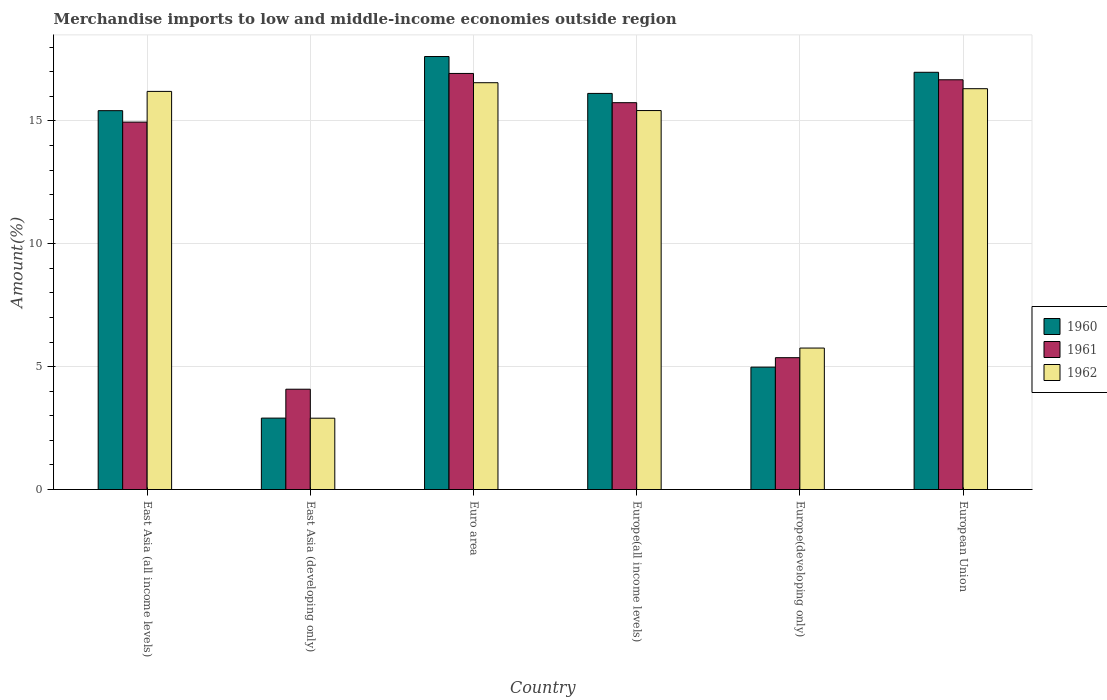How many groups of bars are there?
Your answer should be compact. 6. Are the number of bars per tick equal to the number of legend labels?
Offer a very short reply. Yes. How many bars are there on the 4th tick from the right?
Keep it short and to the point. 3. What is the label of the 4th group of bars from the left?
Provide a short and direct response. Europe(all income levels). In how many cases, is the number of bars for a given country not equal to the number of legend labels?
Keep it short and to the point. 0. What is the percentage of amount earned from merchandise imports in 1961 in Euro area?
Make the answer very short. 16.93. Across all countries, what is the maximum percentage of amount earned from merchandise imports in 1960?
Ensure brevity in your answer.  17.62. Across all countries, what is the minimum percentage of amount earned from merchandise imports in 1960?
Give a very brief answer. 2.91. In which country was the percentage of amount earned from merchandise imports in 1961 minimum?
Provide a short and direct response. East Asia (developing only). What is the total percentage of amount earned from merchandise imports in 1960 in the graph?
Your response must be concise. 74.01. What is the difference between the percentage of amount earned from merchandise imports in 1962 in East Asia (all income levels) and that in East Asia (developing only)?
Make the answer very short. 13.3. What is the difference between the percentage of amount earned from merchandise imports in 1961 in Euro area and the percentage of amount earned from merchandise imports in 1960 in Europe(all income levels)?
Ensure brevity in your answer.  0.81. What is the average percentage of amount earned from merchandise imports in 1961 per country?
Give a very brief answer. 12.29. What is the difference between the percentage of amount earned from merchandise imports of/in 1962 and percentage of amount earned from merchandise imports of/in 1960 in Euro area?
Provide a short and direct response. -1.07. In how many countries, is the percentage of amount earned from merchandise imports in 1962 greater than 10 %?
Provide a succinct answer. 4. What is the ratio of the percentage of amount earned from merchandise imports in 1960 in Europe(all income levels) to that in European Union?
Your answer should be very brief. 0.95. Is the percentage of amount earned from merchandise imports in 1961 in East Asia (developing only) less than that in European Union?
Keep it short and to the point. Yes. Is the difference between the percentage of amount earned from merchandise imports in 1962 in Euro area and Europe(all income levels) greater than the difference between the percentage of amount earned from merchandise imports in 1960 in Euro area and Europe(all income levels)?
Your answer should be compact. No. What is the difference between the highest and the second highest percentage of amount earned from merchandise imports in 1962?
Provide a succinct answer. 0.24. What is the difference between the highest and the lowest percentage of amount earned from merchandise imports in 1962?
Give a very brief answer. 13.65. Is the sum of the percentage of amount earned from merchandise imports in 1962 in East Asia (developing only) and European Union greater than the maximum percentage of amount earned from merchandise imports in 1960 across all countries?
Your answer should be very brief. Yes. What does the 2nd bar from the left in European Union represents?
Make the answer very short. 1961. Are all the bars in the graph horizontal?
Provide a succinct answer. No. How many countries are there in the graph?
Ensure brevity in your answer.  6. Are the values on the major ticks of Y-axis written in scientific E-notation?
Your answer should be compact. No. Does the graph contain any zero values?
Keep it short and to the point. No. How many legend labels are there?
Your answer should be very brief. 3. How are the legend labels stacked?
Make the answer very short. Vertical. What is the title of the graph?
Your response must be concise. Merchandise imports to low and middle-income economies outside region. What is the label or title of the Y-axis?
Your answer should be very brief. Amount(%). What is the Amount(%) of 1960 in East Asia (all income levels)?
Ensure brevity in your answer.  15.41. What is the Amount(%) of 1961 in East Asia (all income levels)?
Provide a short and direct response. 14.95. What is the Amount(%) in 1962 in East Asia (all income levels)?
Provide a succinct answer. 16.2. What is the Amount(%) of 1960 in East Asia (developing only)?
Ensure brevity in your answer.  2.91. What is the Amount(%) in 1961 in East Asia (developing only)?
Your response must be concise. 4.08. What is the Amount(%) of 1962 in East Asia (developing only)?
Provide a succinct answer. 2.9. What is the Amount(%) in 1960 in Euro area?
Provide a succinct answer. 17.62. What is the Amount(%) of 1961 in Euro area?
Your answer should be compact. 16.93. What is the Amount(%) in 1962 in Euro area?
Give a very brief answer. 16.55. What is the Amount(%) in 1960 in Europe(all income levels)?
Your response must be concise. 16.12. What is the Amount(%) of 1961 in Europe(all income levels)?
Provide a short and direct response. 15.74. What is the Amount(%) in 1962 in Europe(all income levels)?
Your response must be concise. 15.42. What is the Amount(%) of 1960 in Europe(developing only)?
Provide a succinct answer. 4.98. What is the Amount(%) of 1961 in Europe(developing only)?
Ensure brevity in your answer.  5.36. What is the Amount(%) in 1962 in Europe(developing only)?
Your response must be concise. 5.76. What is the Amount(%) of 1960 in European Union?
Your answer should be very brief. 16.98. What is the Amount(%) of 1961 in European Union?
Make the answer very short. 16.67. What is the Amount(%) of 1962 in European Union?
Provide a short and direct response. 16.31. Across all countries, what is the maximum Amount(%) of 1960?
Make the answer very short. 17.62. Across all countries, what is the maximum Amount(%) in 1961?
Make the answer very short. 16.93. Across all countries, what is the maximum Amount(%) of 1962?
Give a very brief answer. 16.55. Across all countries, what is the minimum Amount(%) of 1960?
Your response must be concise. 2.91. Across all countries, what is the minimum Amount(%) of 1961?
Your answer should be compact. 4.08. Across all countries, what is the minimum Amount(%) in 1962?
Your response must be concise. 2.9. What is the total Amount(%) in 1960 in the graph?
Your answer should be very brief. 74.01. What is the total Amount(%) of 1961 in the graph?
Offer a terse response. 73.73. What is the total Amount(%) of 1962 in the graph?
Provide a short and direct response. 73.14. What is the difference between the Amount(%) of 1960 in East Asia (all income levels) and that in East Asia (developing only)?
Give a very brief answer. 12.51. What is the difference between the Amount(%) of 1961 in East Asia (all income levels) and that in East Asia (developing only)?
Your answer should be very brief. 10.87. What is the difference between the Amount(%) in 1962 in East Asia (all income levels) and that in East Asia (developing only)?
Provide a succinct answer. 13.3. What is the difference between the Amount(%) in 1960 in East Asia (all income levels) and that in Euro area?
Ensure brevity in your answer.  -2.2. What is the difference between the Amount(%) in 1961 in East Asia (all income levels) and that in Euro area?
Provide a succinct answer. -1.98. What is the difference between the Amount(%) in 1962 in East Asia (all income levels) and that in Euro area?
Offer a very short reply. -0.35. What is the difference between the Amount(%) of 1960 in East Asia (all income levels) and that in Europe(all income levels)?
Provide a short and direct response. -0.7. What is the difference between the Amount(%) in 1961 in East Asia (all income levels) and that in Europe(all income levels)?
Your answer should be very brief. -0.79. What is the difference between the Amount(%) of 1962 in East Asia (all income levels) and that in Europe(all income levels)?
Your response must be concise. 0.78. What is the difference between the Amount(%) of 1960 in East Asia (all income levels) and that in Europe(developing only)?
Ensure brevity in your answer.  10.43. What is the difference between the Amount(%) of 1961 in East Asia (all income levels) and that in Europe(developing only)?
Your response must be concise. 9.58. What is the difference between the Amount(%) in 1962 in East Asia (all income levels) and that in Europe(developing only)?
Your response must be concise. 10.44. What is the difference between the Amount(%) of 1960 in East Asia (all income levels) and that in European Union?
Keep it short and to the point. -1.56. What is the difference between the Amount(%) in 1961 in East Asia (all income levels) and that in European Union?
Provide a succinct answer. -1.72. What is the difference between the Amount(%) of 1962 in East Asia (all income levels) and that in European Union?
Your answer should be very brief. -0.11. What is the difference between the Amount(%) of 1960 in East Asia (developing only) and that in Euro area?
Provide a succinct answer. -14.71. What is the difference between the Amount(%) in 1961 in East Asia (developing only) and that in Euro area?
Ensure brevity in your answer.  -12.85. What is the difference between the Amount(%) of 1962 in East Asia (developing only) and that in Euro area?
Provide a short and direct response. -13.65. What is the difference between the Amount(%) of 1960 in East Asia (developing only) and that in Europe(all income levels)?
Provide a succinct answer. -13.21. What is the difference between the Amount(%) of 1961 in East Asia (developing only) and that in Europe(all income levels)?
Make the answer very short. -11.66. What is the difference between the Amount(%) of 1962 in East Asia (developing only) and that in Europe(all income levels)?
Ensure brevity in your answer.  -12.52. What is the difference between the Amount(%) in 1960 in East Asia (developing only) and that in Europe(developing only)?
Provide a succinct answer. -2.07. What is the difference between the Amount(%) of 1961 in East Asia (developing only) and that in Europe(developing only)?
Ensure brevity in your answer.  -1.28. What is the difference between the Amount(%) in 1962 in East Asia (developing only) and that in Europe(developing only)?
Provide a short and direct response. -2.85. What is the difference between the Amount(%) of 1960 in East Asia (developing only) and that in European Union?
Make the answer very short. -14.07. What is the difference between the Amount(%) in 1961 in East Asia (developing only) and that in European Union?
Provide a succinct answer. -12.59. What is the difference between the Amount(%) in 1962 in East Asia (developing only) and that in European Union?
Provide a short and direct response. -13.41. What is the difference between the Amount(%) in 1960 in Euro area and that in Europe(all income levels)?
Your answer should be very brief. 1.5. What is the difference between the Amount(%) of 1961 in Euro area and that in Europe(all income levels)?
Make the answer very short. 1.19. What is the difference between the Amount(%) in 1962 in Euro area and that in Europe(all income levels)?
Your response must be concise. 1.13. What is the difference between the Amount(%) of 1960 in Euro area and that in Europe(developing only)?
Your answer should be very brief. 12.64. What is the difference between the Amount(%) in 1961 in Euro area and that in Europe(developing only)?
Keep it short and to the point. 11.57. What is the difference between the Amount(%) of 1962 in Euro area and that in Europe(developing only)?
Keep it short and to the point. 10.8. What is the difference between the Amount(%) in 1960 in Euro area and that in European Union?
Offer a very short reply. 0.64. What is the difference between the Amount(%) in 1961 in Euro area and that in European Union?
Provide a succinct answer. 0.26. What is the difference between the Amount(%) of 1962 in Euro area and that in European Union?
Keep it short and to the point. 0.24. What is the difference between the Amount(%) in 1960 in Europe(all income levels) and that in Europe(developing only)?
Your response must be concise. 11.14. What is the difference between the Amount(%) in 1961 in Europe(all income levels) and that in Europe(developing only)?
Give a very brief answer. 10.38. What is the difference between the Amount(%) in 1962 in Europe(all income levels) and that in Europe(developing only)?
Offer a terse response. 9.66. What is the difference between the Amount(%) of 1960 in Europe(all income levels) and that in European Union?
Give a very brief answer. -0.86. What is the difference between the Amount(%) of 1961 in Europe(all income levels) and that in European Union?
Offer a terse response. -0.93. What is the difference between the Amount(%) of 1962 in Europe(all income levels) and that in European Union?
Offer a very short reply. -0.89. What is the difference between the Amount(%) of 1960 in Europe(developing only) and that in European Union?
Give a very brief answer. -12. What is the difference between the Amount(%) of 1961 in Europe(developing only) and that in European Union?
Offer a very short reply. -11.31. What is the difference between the Amount(%) of 1962 in Europe(developing only) and that in European Union?
Provide a short and direct response. -10.55. What is the difference between the Amount(%) in 1960 in East Asia (all income levels) and the Amount(%) in 1961 in East Asia (developing only)?
Offer a very short reply. 11.33. What is the difference between the Amount(%) of 1960 in East Asia (all income levels) and the Amount(%) of 1962 in East Asia (developing only)?
Your answer should be compact. 12.51. What is the difference between the Amount(%) of 1961 in East Asia (all income levels) and the Amount(%) of 1962 in East Asia (developing only)?
Provide a succinct answer. 12.05. What is the difference between the Amount(%) of 1960 in East Asia (all income levels) and the Amount(%) of 1961 in Euro area?
Keep it short and to the point. -1.51. What is the difference between the Amount(%) in 1960 in East Asia (all income levels) and the Amount(%) in 1962 in Euro area?
Your answer should be compact. -1.14. What is the difference between the Amount(%) in 1961 in East Asia (all income levels) and the Amount(%) in 1962 in Euro area?
Offer a very short reply. -1.6. What is the difference between the Amount(%) of 1960 in East Asia (all income levels) and the Amount(%) of 1961 in Europe(all income levels)?
Keep it short and to the point. -0.32. What is the difference between the Amount(%) in 1960 in East Asia (all income levels) and the Amount(%) in 1962 in Europe(all income levels)?
Give a very brief answer. -0. What is the difference between the Amount(%) in 1961 in East Asia (all income levels) and the Amount(%) in 1962 in Europe(all income levels)?
Offer a terse response. -0.47. What is the difference between the Amount(%) in 1960 in East Asia (all income levels) and the Amount(%) in 1961 in Europe(developing only)?
Offer a very short reply. 10.05. What is the difference between the Amount(%) of 1960 in East Asia (all income levels) and the Amount(%) of 1962 in Europe(developing only)?
Offer a very short reply. 9.66. What is the difference between the Amount(%) in 1961 in East Asia (all income levels) and the Amount(%) in 1962 in Europe(developing only)?
Your answer should be compact. 9.19. What is the difference between the Amount(%) of 1960 in East Asia (all income levels) and the Amount(%) of 1961 in European Union?
Offer a very short reply. -1.26. What is the difference between the Amount(%) of 1960 in East Asia (all income levels) and the Amount(%) of 1962 in European Union?
Your response must be concise. -0.89. What is the difference between the Amount(%) of 1961 in East Asia (all income levels) and the Amount(%) of 1962 in European Union?
Your answer should be compact. -1.36. What is the difference between the Amount(%) in 1960 in East Asia (developing only) and the Amount(%) in 1961 in Euro area?
Your response must be concise. -14.02. What is the difference between the Amount(%) of 1960 in East Asia (developing only) and the Amount(%) of 1962 in Euro area?
Provide a succinct answer. -13.65. What is the difference between the Amount(%) in 1961 in East Asia (developing only) and the Amount(%) in 1962 in Euro area?
Offer a terse response. -12.47. What is the difference between the Amount(%) of 1960 in East Asia (developing only) and the Amount(%) of 1961 in Europe(all income levels)?
Your answer should be compact. -12.83. What is the difference between the Amount(%) in 1960 in East Asia (developing only) and the Amount(%) in 1962 in Europe(all income levels)?
Ensure brevity in your answer.  -12.51. What is the difference between the Amount(%) in 1961 in East Asia (developing only) and the Amount(%) in 1962 in Europe(all income levels)?
Give a very brief answer. -11.34. What is the difference between the Amount(%) of 1960 in East Asia (developing only) and the Amount(%) of 1961 in Europe(developing only)?
Your answer should be very brief. -2.46. What is the difference between the Amount(%) in 1960 in East Asia (developing only) and the Amount(%) in 1962 in Europe(developing only)?
Offer a very short reply. -2.85. What is the difference between the Amount(%) of 1961 in East Asia (developing only) and the Amount(%) of 1962 in Europe(developing only)?
Provide a succinct answer. -1.67. What is the difference between the Amount(%) in 1960 in East Asia (developing only) and the Amount(%) in 1961 in European Union?
Your response must be concise. -13.77. What is the difference between the Amount(%) in 1960 in East Asia (developing only) and the Amount(%) in 1962 in European Union?
Provide a succinct answer. -13.4. What is the difference between the Amount(%) in 1961 in East Asia (developing only) and the Amount(%) in 1962 in European Union?
Your answer should be very brief. -12.23. What is the difference between the Amount(%) in 1960 in Euro area and the Amount(%) in 1961 in Europe(all income levels)?
Keep it short and to the point. 1.88. What is the difference between the Amount(%) in 1960 in Euro area and the Amount(%) in 1962 in Europe(all income levels)?
Provide a short and direct response. 2.2. What is the difference between the Amount(%) in 1961 in Euro area and the Amount(%) in 1962 in Europe(all income levels)?
Provide a short and direct response. 1.51. What is the difference between the Amount(%) of 1960 in Euro area and the Amount(%) of 1961 in Europe(developing only)?
Your answer should be very brief. 12.25. What is the difference between the Amount(%) of 1960 in Euro area and the Amount(%) of 1962 in Europe(developing only)?
Your answer should be compact. 11.86. What is the difference between the Amount(%) of 1961 in Euro area and the Amount(%) of 1962 in Europe(developing only)?
Give a very brief answer. 11.17. What is the difference between the Amount(%) in 1960 in Euro area and the Amount(%) in 1961 in European Union?
Ensure brevity in your answer.  0.95. What is the difference between the Amount(%) of 1960 in Euro area and the Amount(%) of 1962 in European Union?
Your answer should be very brief. 1.31. What is the difference between the Amount(%) of 1961 in Euro area and the Amount(%) of 1962 in European Union?
Offer a very short reply. 0.62. What is the difference between the Amount(%) of 1960 in Europe(all income levels) and the Amount(%) of 1961 in Europe(developing only)?
Offer a terse response. 10.75. What is the difference between the Amount(%) in 1960 in Europe(all income levels) and the Amount(%) in 1962 in Europe(developing only)?
Provide a succinct answer. 10.36. What is the difference between the Amount(%) in 1961 in Europe(all income levels) and the Amount(%) in 1962 in Europe(developing only)?
Give a very brief answer. 9.98. What is the difference between the Amount(%) of 1960 in Europe(all income levels) and the Amount(%) of 1961 in European Union?
Make the answer very short. -0.55. What is the difference between the Amount(%) of 1960 in Europe(all income levels) and the Amount(%) of 1962 in European Union?
Provide a short and direct response. -0.19. What is the difference between the Amount(%) in 1961 in Europe(all income levels) and the Amount(%) in 1962 in European Union?
Your response must be concise. -0.57. What is the difference between the Amount(%) in 1960 in Europe(developing only) and the Amount(%) in 1961 in European Union?
Ensure brevity in your answer.  -11.69. What is the difference between the Amount(%) of 1960 in Europe(developing only) and the Amount(%) of 1962 in European Union?
Ensure brevity in your answer.  -11.33. What is the difference between the Amount(%) of 1961 in Europe(developing only) and the Amount(%) of 1962 in European Union?
Your answer should be very brief. -10.94. What is the average Amount(%) in 1960 per country?
Your answer should be compact. 12.33. What is the average Amount(%) in 1961 per country?
Your answer should be very brief. 12.29. What is the average Amount(%) in 1962 per country?
Give a very brief answer. 12.19. What is the difference between the Amount(%) in 1960 and Amount(%) in 1961 in East Asia (all income levels)?
Keep it short and to the point. 0.47. What is the difference between the Amount(%) in 1960 and Amount(%) in 1962 in East Asia (all income levels)?
Provide a succinct answer. -0.78. What is the difference between the Amount(%) in 1961 and Amount(%) in 1962 in East Asia (all income levels)?
Make the answer very short. -1.25. What is the difference between the Amount(%) of 1960 and Amount(%) of 1961 in East Asia (developing only)?
Ensure brevity in your answer.  -1.18. What is the difference between the Amount(%) of 1960 and Amount(%) of 1962 in East Asia (developing only)?
Your answer should be very brief. 0. What is the difference between the Amount(%) of 1961 and Amount(%) of 1962 in East Asia (developing only)?
Give a very brief answer. 1.18. What is the difference between the Amount(%) in 1960 and Amount(%) in 1961 in Euro area?
Ensure brevity in your answer.  0.69. What is the difference between the Amount(%) of 1960 and Amount(%) of 1962 in Euro area?
Make the answer very short. 1.07. What is the difference between the Amount(%) in 1961 and Amount(%) in 1962 in Euro area?
Keep it short and to the point. 0.38. What is the difference between the Amount(%) in 1960 and Amount(%) in 1961 in Europe(all income levels)?
Your answer should be compact. 0.38. What is the difference between the Amount(%) of 1960 and Amount(%) of 1962 in Europe(all income levels)?
Give a very brief answer. 0.7. What is the difference between the Amount(%) in 1961 and Amount(%) in 1962 in Europe(all income levels)?
Make the answer very short. 0.32. What is the difference between the Amount(%) in 1960 and Amount(%) in 1961 in Europe(developing only)?
Offer a very short reply. -0.38. What is the difference between the Amount(%) of 1960 and Amount(%) of 1962 in Europe(developing only)?
Offer a very short reply. -0.78. What is the difference between the Amount(%) of 1961 and Amount(%) of 1962 in Europe(developing only)?
Your response must be concise. -0.39. What is the difference between the Amount(%) of 1960 and Amount(%) of 1961 in European Union?
Provide a succinct answer. 0.3. What is the difference between the Amount(%) of 1960 and Amount(%) of 1962 in European Union?
Make the answer very short. 0.67. What is the difference between the Amount(%) of 1961 and Amount(%) of 1962 in European Union?
Your response must be concise. 0.36. What is the ratio of the Amount(%) of 1960 in East Asia (all income levels) to that in East Asia (developing only)?
Your answer should be compact. 5.3. What is the ratio of the Amount(%) in 1961 in East Asia (all income levels) to that in East Asia (developing only)?
Make the answer very short. 3.66. What is the ratio of the Amount(%) of 1962 in East Asia (all income levels) to that in East Asia (developing only)?
Make the answer very short. 5.58. What is the ratio of the Amount(%) of 1960 in East Asia (all income levels) to that in Euro area?
Make the answer very short. 0.88. What is the ratio of the Amount(%) of 1961 in East Asia (all income levels) to that in Euro area?
Keep it short and to the point. 0.88. What is the ratio of the Amount(%) in 1962 in East Asia (all income levels) to that in Euro area?
Your response must be concise. 0.98. What is the ratio of the Amount(%) in 1960 in East Asia (all income levels) to that in Europe(all income levels)?
Offer a terse response. 0.96. What is the ratio of the Amount(%) of 1961 in East Asia (all income levels) to that in Europe(all income levels)?
Provide a succinct answer. 0.95. What is the ratio of the Amount(%) of 1962 in East Asia (all income levels) to that in Europe(all income levels)?
Provide a short and direct response. 1.05. What is the ratio of the Amount(%) of 1960 in East Asia (all income levels) to that in Europe(developing only)?
Your answer should be compact. 3.1. What is the ratio of the Amount(%) in 1961 in East Asia (all income levels) to that in Europe(developing only)?
Provide a short and direct response. 2.79. What is the ratio of the Amount(%) of 1962 in East Asia (all income levels) to that in Europe(developing only)?
Offer a very short reply. 2.81. What is the ratio of the Amount(%) of 1960 in East Asia (all income levels) to that in European Union?
Offer a very short reply. 0.91. What is the ratio of the Amount(%) of 1961 in East Asia (all income levels) to that in European Union?
Give a very brief answer. 0.9. What is the ratio of the Amount(%) in 1960 in East Asia (developing only) to that in Euro area?
Provide a succinct answer. 0.16. What is the ratio of the Amount(%) in 1961 in East Asia (developing only) to that in Euro area?
Your answer should be very brief. 0.24. What is the ratio of the Amount(%) of 1962 in East Asia (developing only) to that in Euro area?
Make the answer very short. 0.18. What is the ratio of the Amount(%) of 1960 in East Asia (developing only) to that in Europe(all income levels)?
Keep it short and to the point. 0.18. What is the ratio of the Amount(%) of 1961 in East Asia (developing only) to that in Europe(all income levels)?
Your response must be concise. 0.26. What is the ratio of the Amount(%) in 1962 in East Asia (developing only) to that in Europe(all income levels)?
Make the answer very short. 0.19. What is the ratio of the Amount(%) of 1960 in East Asia (developing only) to that in Europe(developing only)?
Your response must be concise. 0.58. What is the ratio of the Amount(%) in 1961 in East Asia (developing only) to that in Europe(developing only)?
Give a very brief answer. 0.76. What is the ratio of the Amount(%) in 1962 in East Asia (developing only) to that in Europe(developing only)?
Provide a short and direct response. 0.5. What is the ratio of the Amount(%) in 1960 in East Asia (developing only) to that in European Union?
Make the answer very short. 0.17. What is the ratio of the Amount(%) in 1961 in East Asia (developing only) to that in European Union?
Ensure brevity in your answer.  0.24. What is the ratio of the Amount(%) of 1962 in East Asia (developing only) to that in European Union?
Keep it short and to the point. 0.18. What is the ratio of the Amount(%) of 1960 in Euro area to that in Europe(all income levels)?
Offer a very short reply. 1.09. What is the ratio of the Amount(%) of 1961 in Euro area to that in Europe(all income levels)?
Keep it short and to the point. 1.08. What is the ratio of the Amount(%) in 1962 in Euro area to that in Europe(all income levels)?
Your response must be concise. 1.07. What is the ratio of the Amount(%) in 1960 in Euro area to that in Europe(developing only)?
Make the answer very short. 3.54. What is the ratio of the Amount(%) of 1961 in Euro area to that in Europe(developing only)?
Keep it short and to the point. 3.16. What is the ratio of the Amount(%) in 1962 in Euro area to that in Europe(developing only)?
Offer a very short reply. 2.88. What is the ratio of the Amount(%) of 1960 in Euro area to that in European Union?
Offer a terse response. 1.04. What is the ratio of the Amount(%) of 1961 in Euro area to that in European Union?
Provide a succinct answer. 1.02. What is the ratio of the Amount(%) of 1962 in Euro area to that in European Union?
Give a very brief answer. 1.01. What is the ratio of the Amount(%) of 1960 in Europe(all income levels) to that in Europe(developing only)?
Make the answer very short. 3.24. What is the ratio of the Amount(%) in 1961 in Europe(all income levels) to that in Europe(developing only)?
Provide a short and direct response. 2.93. What is the ratio of the Amount(%) of 1962 in Europe(all income levels) to that in Europe(developing only)?
Give a very brief answer. 2.68. What is the ratio of the Amount(%) of 1960 in Europe(all income levels) to that in European Union?
Your response must be concise. 0.95. What is the ratio of the Amount(%) in 1961 in Europe(all income levels) to that in European Union?
Make the answer very short. 0.94. What is the ratio of the Amount(%) of 1962 in Europe(all income levels) to that in European Union?
Make the answer very short. 0.95. What is the ratio of the Amount(%) of 1960 in Europe(developing only) to that in European Union?
Give a very brief answer. 0.29. What is the ratio of the Amount(%) of 1961 in Europe(developing only) to that in European Union?
Make the answer very short. 0.32. What is the ratio of the Amount(%) of 1962 in Europe(developing only) to that in European Union?
Make the answer very short. 0.35. What is the difference between the highest and the second highest Amount(%) of 1960?
Offer a very short reply. 0.64. What is the difference between the highest and the second highest Amount(%) in 1961?
Your response must be concise. 0.26. What is the difference between the highest and the second highest Amount(%) of 1962?
Your answer should be very brief. 0.24. What is the difference between the highest and the lowest Amount(%) of 1960?
Provide a succinct answer. 14.71. What is the difference between the highest and the lowest Amount(%) of 1961?
Provide a succinct answer. 12.85. What is the difference between the highest and the lowest Amount(%) of 1962?
Give a very brief answer. 13.65. 